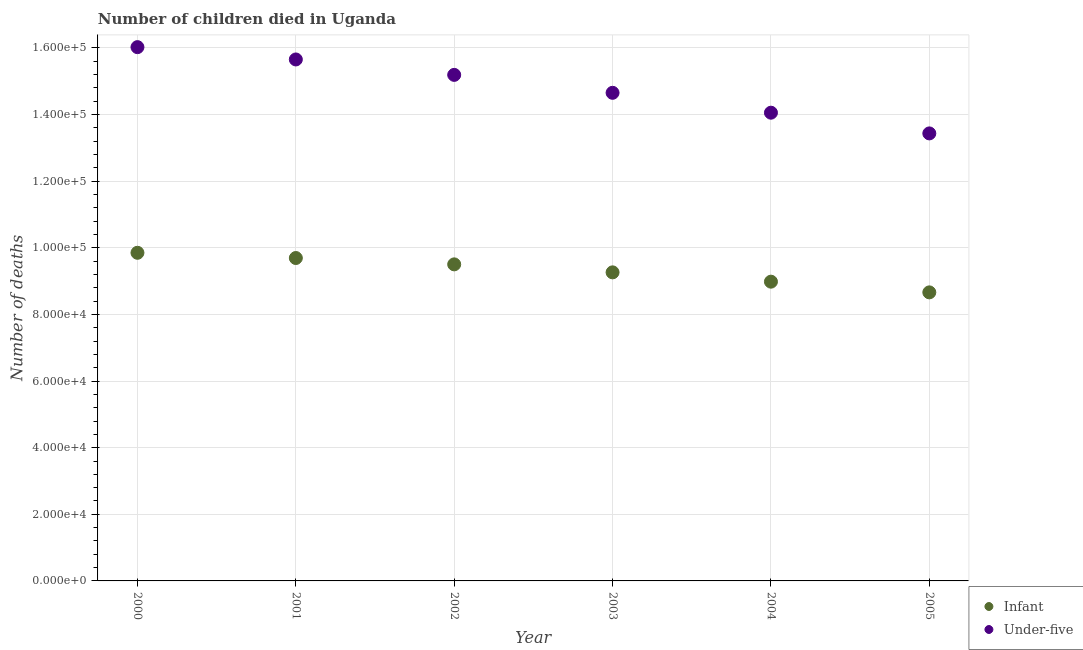How many different coloured dotlines are there?
Your answer should be compact. 2. Is the number of dotlines equal to the number of legend labels?
Ensure brevity in your answer.  Yes. What is the number of under-five deaths in 2001?
Provide a short and direct response. 1.57e+05. Across all years, what is the maximum number of under-five deaths?
Provide a short and direct response. 1.60e+05. Across all years, what is the minimum number of infant deaths?
Offer a terse response. 8.66e+04. What is the total number of infant deaths in the graph?
Provide a short and direct response. 5.60e+05. What is the difference between the number of under-five deaths in 2000 and that in 2005?
Your answer should be compact. 2.59e+04. What is the difference between the number of infant deaths in 2002 and the number of under-five deaths in 2004?
Your response must be concise. -4.55e+04. What is the average number of infant deaths per year?
Your answer should be compact. 9.33e+04. In the year 2004, what is the difference between the number of infant deaths and number of under-five deaths?
Offer a very short reply. -5.07e+04. In how many years, is the number of infant deaths greater than 96000?
Keep it short and to the point. 2. What is the ratio of the number of under-five deaths in 2002 to that in 2004?
Keep it short and to the point. 1.08. Is the number of infant deaths in 2002 less than that in 2004?
Your response must be concise. No. Is the difference between the number of infant deaths in 2001 and 2004 greater than the difference between the number of under-five deaths in 2001 and 2004?
Ensure brevity in your answer.  No. What is the difference between the highest and the second highest number of under-five deaths?
Your answer should be compact. 3699. What is the difference between the highest and the lowest number of infant deaths?
Ensure brevity in your answer.  1.19e+04. Is the sum of the number of infant deaths in 2003 and 2004 greater than the maximum number of under-five deaths across all years?
Offer a terse response. Yes. Does the number of under-five deaths monotonically increase over the years?
Give a very brief answer. No. How many dotlines are there?
Your answer should be very brief. 2. How many years are there in the graph?
Make the answer very short. 6. Does the graph contain any zero values?
Provide a succinct answer. No. Does the graph contain grids?
Provide a short and direct response. Yes. How many legend labels are there?
Your answer should be compact. 2. What is the title of the graph?
Your answer should be very brief. Number of children died in Uganda. What is the label or title of the X-axis?
Make the answer very short. Year. What is the label or title of the Y-axis?
Provide a short and direct response. Number of deaths. What is the Number of deaths of Infant in 2000?
Provide a succinct answer. 9.85e+04. What is the Number of deaths of Under-five in 2000?
Provide a succinct answer. 1.60e+05. What is the Number of deaths in Infant in 2001?
Offer a very short reply. 9.69e+04. What is the Number of deaths of Under-five in 2001?
Offer a very short reply. 1.57e+05. What is the Number of deaths of Infant in 2002?
Ensure brevity in your answer.  9.50e+04. What is the Number of deaths in Under-five in 2002?
Give a very brief answer. 1.52e+05. What is the Number of deaths of Infant in 2003?
Give a very brief answer. 9.26e+04. What is the Number of deaths in Under-five in 2003?
Provide a succinct answer. 1.47e+05. What is the Number of deaths of Infant in 2004?
Your answer should be very brief. 8.98e+04. What is the Number of deaths of Under-five in 2004?
Provide a short and direct response. 1.41e+05. What is the Number of deaths of Infant in 2005?
Keep it short and to the point. 8.66e+04. What is the Number of deaths in Under-five in 2005?
Your answer should be very brief. 1.34e+05. Across all years, what is the maximum Number of deaths of Infant?
Ensure brevity in your answer.  9.85e+04. Across all years, what is the maximum Number of deaths in Under-five?
Offer a very short reply. 1.60e+05. Across all years, what is the minimum Number of deaths of Infant?
Your response must be concise. 8.66e+04. Across all years, what is the minimum Number of deaths in Under-five?
Offer a terse response. 1.34e+05. What is the total Number of deaths in Infant in the graph?
Offer a terse response. 5.60e+05. What is the total Number of deaths of Under-five in the graph?
Offer a terse response. 8.90e+05. What is the difference between the Number of deaths in Infant in 2000 and that in 2001?
Your answer should be compact. 1572. What is the difference between the Number of deaths of Under-five in 2000 and that in 2001?
Provide a short and direct response. 3699. What is the difference between the Number of deaths of Infant in 2000 and that in 2002?
Provide a short and direct response. 3476. What is the difference between the Number of deaths in Under-five in 2000 and that in 2002?
Provide a succinct answer. 8329. What is the difference between the Number of deaths of Infant in 2000 and that in 2003?
Your answer should be very brief. 5875. What is the difference between the Number of deaths in Under-five in 2000 and that in 2003?
Make the answer very short. 1.37e+04. What is the difference between the Number of deaths of Infant in 2000 and that in 2004?
Your response must be concise. 8672. What is the difference between the Number of deaths of Under-five in 2000 and that in 2004?
Give a very brief answer. 1.97e+04. What is the difference between the Number of deaths of Infant in 2000 and that in 2005?
Offer a terse response. 1.19e+04. What is the difference between the Number of deaths in Under-five in 2000 and that in 2005?
Ensure brevity in your answer.  2.59e+04. What is the difference between the Number of deaths in Infant in 2001 and that in 2002?
Make the answer very short. 1904. What is the difference between the Number of deaths of Under-five in 2001 and that in 2002?
Your answer should be compact. 4630. What is the difference between the Number of deaths of Infant in 2001 and that in 2003?
Your answer should be compact. 4303. What is the difference between the Number of deaths of Under-five in 2001 and that in 2003?
Keep it short and to the point. 1.00e+04. What is the difference between the Number of deaths in Infant in 2001 and that in 2004?
Ensure brevity in your answer.  7100. What is the difference between the Number of deaths of Under-five in 2001 and that in 2004?
Provide a short and direct response. 1.60e+04. What is the difference between the Number of deaths in Infant in 2001 and that in 2005?
Your answer should be very brief. 1.03e+04. What is the difference between the Number of deaths of Under-five in 2001 and that in 2005?
Your response must be concise. 2.22e+04. What is the difference between the Number of deaths in Infant in 2002 and that in 2003?
Your answer should be compact. 2399. What is the difference between the Number of deaths in Under-five in 2002 and that in 2003?
Provide a short and direct response. 5384. What is the difference between the Number of deaths of Infant in 2002 and that in 2004?
Offer a very short reply. 5196. What is the difference between the Number of deaths of Under-five in 2002 and that in 2004?
Offer a terse response. 1.14e+04. What is the difference between the Number of deaths in Infant in 2002 and that in 2005?
Offer a very short reply. 8408. What is the difference between the Number of deaths of Under-five in 2002 and that in 2005?
Your response must be concise. 1.76e+04. What is the difference between the Number of deaths in Infant in 2003 and that in 2004?
Give a very brief answer. 2797. What is the difference between the Number of deaths of Under-five in 2003 and that in 2004?
Give a very brief answer. 5968. What is the difference between the Number of deaths of Infant in 2003 and that in 2005?
Your answer should be very brief. 6009. What is the difference between the Number of deaths of Under-five in 2003 and that in 2005?
Keep it short and to the point. 1.22e+04. What is the difference between the Number of deaths in Infant in 2004 and that in 2005?
Give a very brief answer. 3212. What is the difference between the Number of deaths of Under-five in 2004 and that in 2005?
Provide a succinct answer. 6218. What is the difference between the Number of deaths in Infant in 2000 and the Number of deaths in Under-five in 2001?
Provide a succinct answer. -5.80e+04. What is the difference between the Number of deaths of Infant in 2000 and the Number of deaths of Under-five in 2002?
Give a very brief answer. -5.34e+04. What is the difference between the Number of deaths of Infant in 2000 and the Number of deaths of Under-five in 2003?
Your response must be concise. -4.80e+04. What is the difference between the Number of deaths of Infant in 2000 and the Number of deaths of Under-five in 2004?
Your answer should be very brief. -4.21e+04. What is the difference between the Number of deaths in Infant in 2000 and the Number of deaths in Under-five in 2005?
Provide a short and direct response. -3.58e+04. What is the difference between the Number of deaths of Infant in 2001 and the Number of deaths of Under-five in 2002?
Provide a short and direct response. -5.50e+04. What is the difference between the Number of deaths in Infant in 2001 and the Number of deaths in Under-five in 2003?
Your answer should be very brief. -4.96e+04. What is the difference between the Number of deaths of Infant in 2001 and the Number of deaths of Under-five in 2004?
Keep it short and to the point. -4.36e+04. What is the difference between the Number of deaths of Infant in 2001 and the Number of deaths of Under-five in 2005?
Provide a succinct answer. -3.74e+04. What is the difference between the Number of deaths in Infant in 2002 and the Number of deaths in Under-five in 2003?
Offer a terse response. -5.15e+04. What is the difference between the Number of deaths in Infant in 2002 and the Number of deaths in Under-five in 2004?
Your answer should be very brief. -4.55e+04. What is the difference between the Number of deaths of Infant in 2002 and the Number of deaths of Under-five in 2005?
Provide a short and direct response. -3.93e+04. What is the difference between the Number of deaths of Infant in 2003 and the Number of deaths of Under-five in 2004?
Give a very brief answer. -4.79e+04. What is the difference between the Number of deaths of Infant in 2003 and the Number of deaths of Under-five in 2005?
Offer a very short reply. -4.17e+04. What is the difference between the Number of deaths of Infant in 2004 and the Number of deaths of Under-five in 2005?
Ensure brevity in your answer.  -4.45e+04. What is the average Number of deaths in Infant per year?
Provide a succinct answer. 9.33e+04. What is the average Number of deaths of Under-five per year?
Give a very brief answer. 1.48e+05. In the year 2000, what is the difference between the Number of deaths in Infant and Number of deaths in Under-five?
Your response must be concise. -6.17e+04. In the year 2001, what is the difference between the Number of deaths of Infant and Number of deaths of Under-five?
Ensure brevity in your answer.  -5.96e+04. In the year 2002, what is the difference between the Number of deaths in Infant and Number of deaths in Under-five?
Provide a short and direct response. -5.69e+04. In the year 2003, what is the difference between the Number of deaths of Infant and Number of deaths of Under-five?
Provide a succinct answer. -5.39e+04. In the year 2004, what is the difference between the Number of deaths in Infant and Number of deaths in Under-five?
Ensure brevity in your answer.  -5.07e+04. In the year 2005, what is the difference between the Number of deaths of Infant and Number of deaths of Under-five?
Ensure brevity in your answer.  -4.77e+04. What is the ratio of the Number of deaths in Infant in 2000 to that in 2001?
Your answer should be compact. 1.02. What is the ratio of the Number of deaths of Under-five in 2000 to that in 2001?
Offer a very short reply. 1.02. What is the ratio of the Number of deaths in Infant in 2000 to that in 2002?
Give a very brief answer. 1.04. What is the ratio of the Number of deaths in Under-five in 2000 to that in 2002?
Ensure brevity in your answer.  1.05. What is the ratio of the Number of deaths of Infant in 2000 to that in 2003?
Ensure brevity in your answer.  1.06. What is the ratio of the Number of deaths of Under-five in 2000 to that in 2003?
Your answer should be compact. 1.09. What is the ratio of the Number of deaths of Infant in 2000 to that in 2004?
Your answer should be very brief. 1.1. What is the ratio of the Number of deaths of Under-five in 2000 to that in 2004?
Ensure brevity in your answer.  1.14. What is the ratio of the Number of deaths of Infant in 2000 to that in 2005?
Make the answer very short. 1.14. What is the ratio of the Number of deaths in Under-five in 2000 to that in 2005?
Make the answer very short. 1.19. What is the ratio of the Number of deaths in Under-five in 2001 to that in 2002?
Offer a terse response. 1.03. What is the ratio of the Number of deaths of Infant in 2001 to that in 2003?
Your answer should be very brief. 1.05. What is the ratio of the Number of deaths in Under-five in 2001 to that in 2003?
Give a very brief answer. 1.07. What is the ratio of the Number of deaths in Infant in 2001 to that in 2004?
Provide a succinct answer. 1.08. What is the ratio of the Number of deaths in Under-five in 2001 to that in 2004?
Offer a very short reply. 1.11. What is the ratio of the Number of deaths in Infant in 2001 to that in 2005?
Make the answer very short. 1.12. What is the ratio of the Number of deaths in Under-five in 2001 to that in 2005?
Keep it short and to the point. 1.17. What is the ratio of the Number of deaths in Infant in 2002 to that in 2003?
Give a very brief answer. 1.03. What is the ratio of the Number of deaths in Under-five in 2002 to that in 2003?
Your answer should be very brief. 1.04. What is the ratio of the Number of deaths of Infant in 2002 to that in 2004?
Your answer should be compact. 1.06. What is the ratio of the Number of deaths of Under-five in 2002 to that in 2004?
Your answer should be compact. 1.08. What is the ratio of the Number of deaths in Infant in 2002 to that in 2005?
Ensure brevity in your answer.  1.1. What is the ratio of the Number of deaths in Under-five in 2002 to that in 2005?
Give a very brief answer. 1.13. What is the ratio of the Number of deaths in Infant in 2003 to that in 2004?
Ensure brevity in your answer.  1.03. What is the ratio of the Number of deaths of Under-five in 2003 to that in 2004?
Give a very brief answer. 1.04. What is the ratio of the Number of deaths of Infant in 2003 to that in 2005?
Your answer should be compact. 1.07. What is the ratio of the Number of deaths of Under-five in 2003 to that in 2005?
Give a very brief answer. 1.09. What is the ratio of the Number of deaths of Infant in 2004 to that in 2005?
Keep it short and to the point. 1.04. What is the ratio of the Number of deaths in Under-five in 2004 to that in 2005?
Keep it short and to the point. 1.05. What is the difference between the highest and the second highest Number of deaths of Infant?
Offer a terse response. 1572. What is the difference between the highest and the second highest Number of deaths in Under-five?
Your answer should be very brief. 3699. What is the difference between the highest and the lowest Number of deaths in Infant?
Ensure brevity in your answer.  1.19e+04. What is the difference between the highest and the lowest Number of deaths of Under-five?
Offer a terse response. 2.59e+04. 